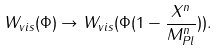<formula> <loc_0><loc_0><loc_500><loc_500>W _ { v i s } ( \Phi ) \rightarrow W _ { v i s } ( \Phi ( 1 - \frac { X ^ { n } } { M _ { P l } ^ { n } } ) ) .</formula> 